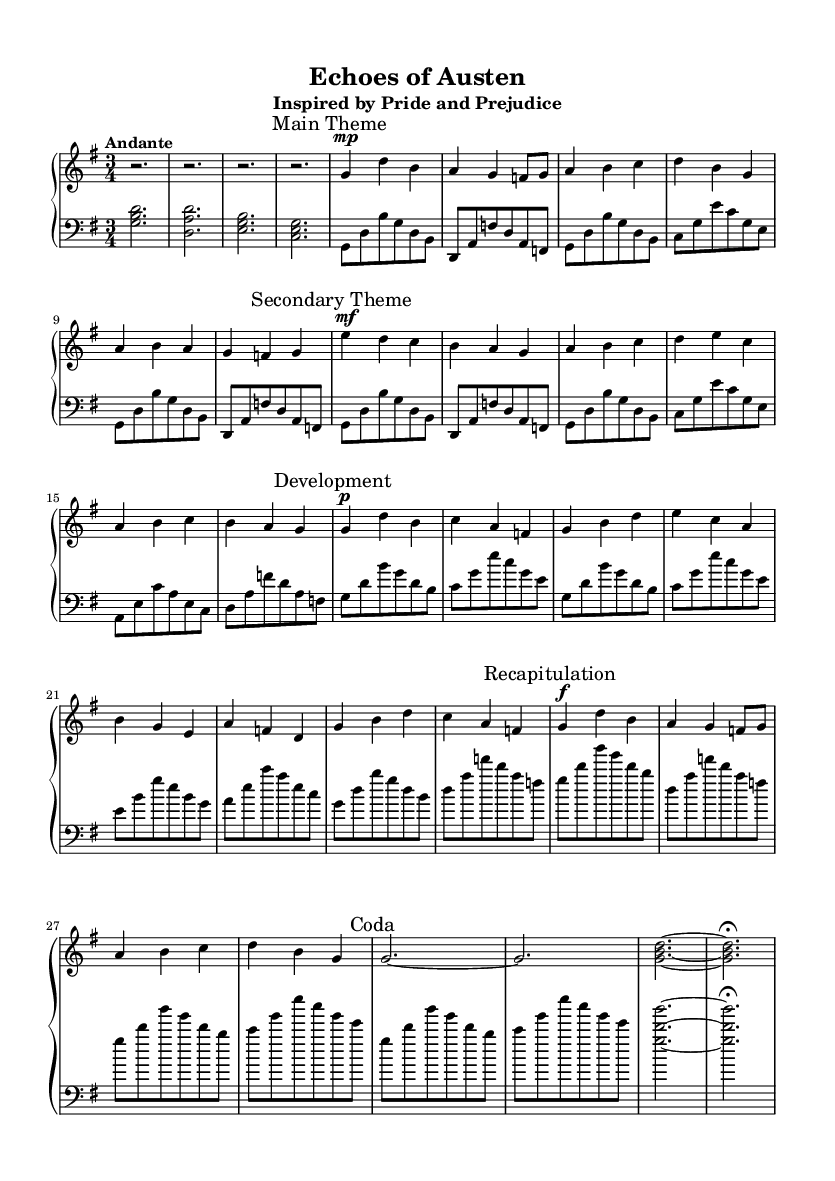What is the key signature of this music? The key signature is G major, which has one sharp (F#).
Answer: G major What is the time signature of this composition? The time signature is 3/4, indicating three beats per measure.
Answer: 3/4 What is the tempo marking given in the music? The tempo marking indicates "Andante," which suggests a moderately slow pace.
Answer: Andante How many main sections are identified in the music? The music includes three main sections: Main Theme, Secondary Theme, and Development, plus a Recapitulation and Coda.
Answer: Five In which literary work is this composition inspired? The composition is inspired by "Pride and Prejudice" by Jane Austen, as mentioned in the subtitle.
Answer: Pride and Prejudice What dynamic marking is indicated at the beginning of the Secondary Theme? The Secondary Theme begins with a "mf" marking, which stands for mezzo-forte, meaning moderately loud.
Answer: mf How does the Development section primarily differ from the Main Theme? The Development section explores different motifs and variations but is simplified due to space constraints, unlike the Main Theme which is more straightforward.
Answer: Simplified exploration 